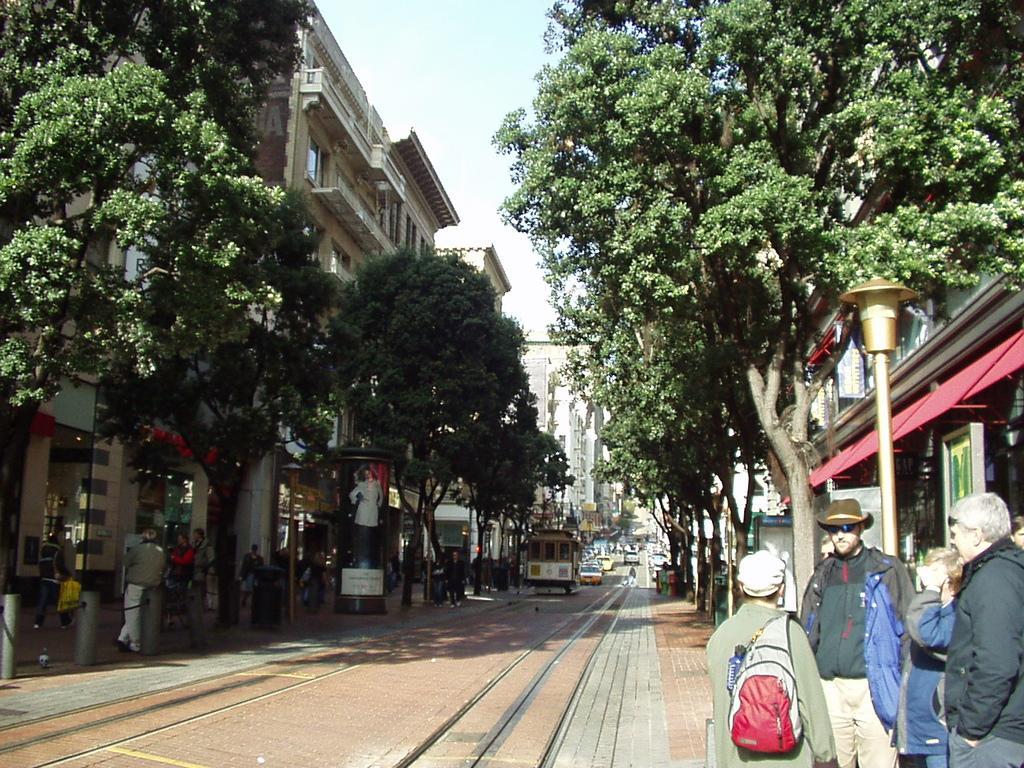In one or two sentences, can you explain what this image depicts? This picture is taken in the street. In the center, there are trains tracks on the road. In either side of the track, there are buildings and trees. At the bottom right, there are people wearing jackets. One of the man is carrying a bag. Towards the bottom left, there are people and poles. On the top, there is a sky. 